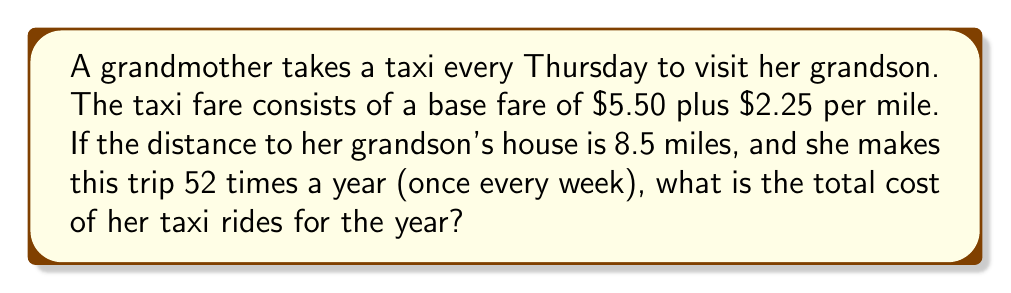Provide a solution to this math problem. Let's break this problem down step-by-step:

1. Calculate the cost of a single trip:
   - Base fare: $5.50
   - Per mile charge: $2.25 × 8.5 miles = $19.125
   - Total for one trip: $5.50 + $19.125 = $24.625

2. Calculate the cost for the entire year:
   - Number of trips per year: 52 (once every week)
   - Total cost = Cost per trip × Number of trips
   
   $$\text{Total cost} = $24.625 \times 52$$

3. Perform the calculation:
   $$\text{Total cost} = $24.625 \times 52 = $1,280.50$$

Note: In real-world scenarios, taxi fares are usually rounded to the nearest cent, but for the purpose of this calculation, we've carried the exact amount through to the final step.
Answer: $1,280.50 